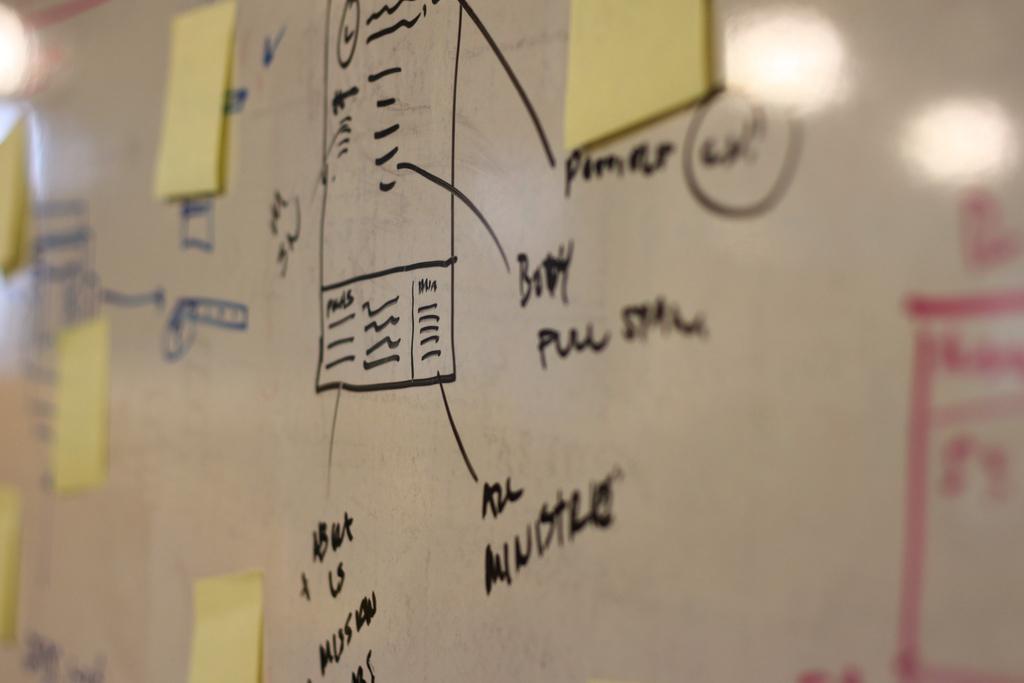Can you describe this image briefly? In this image there are few papers attached to the board, there is some text and some reflections of lights on the board. 